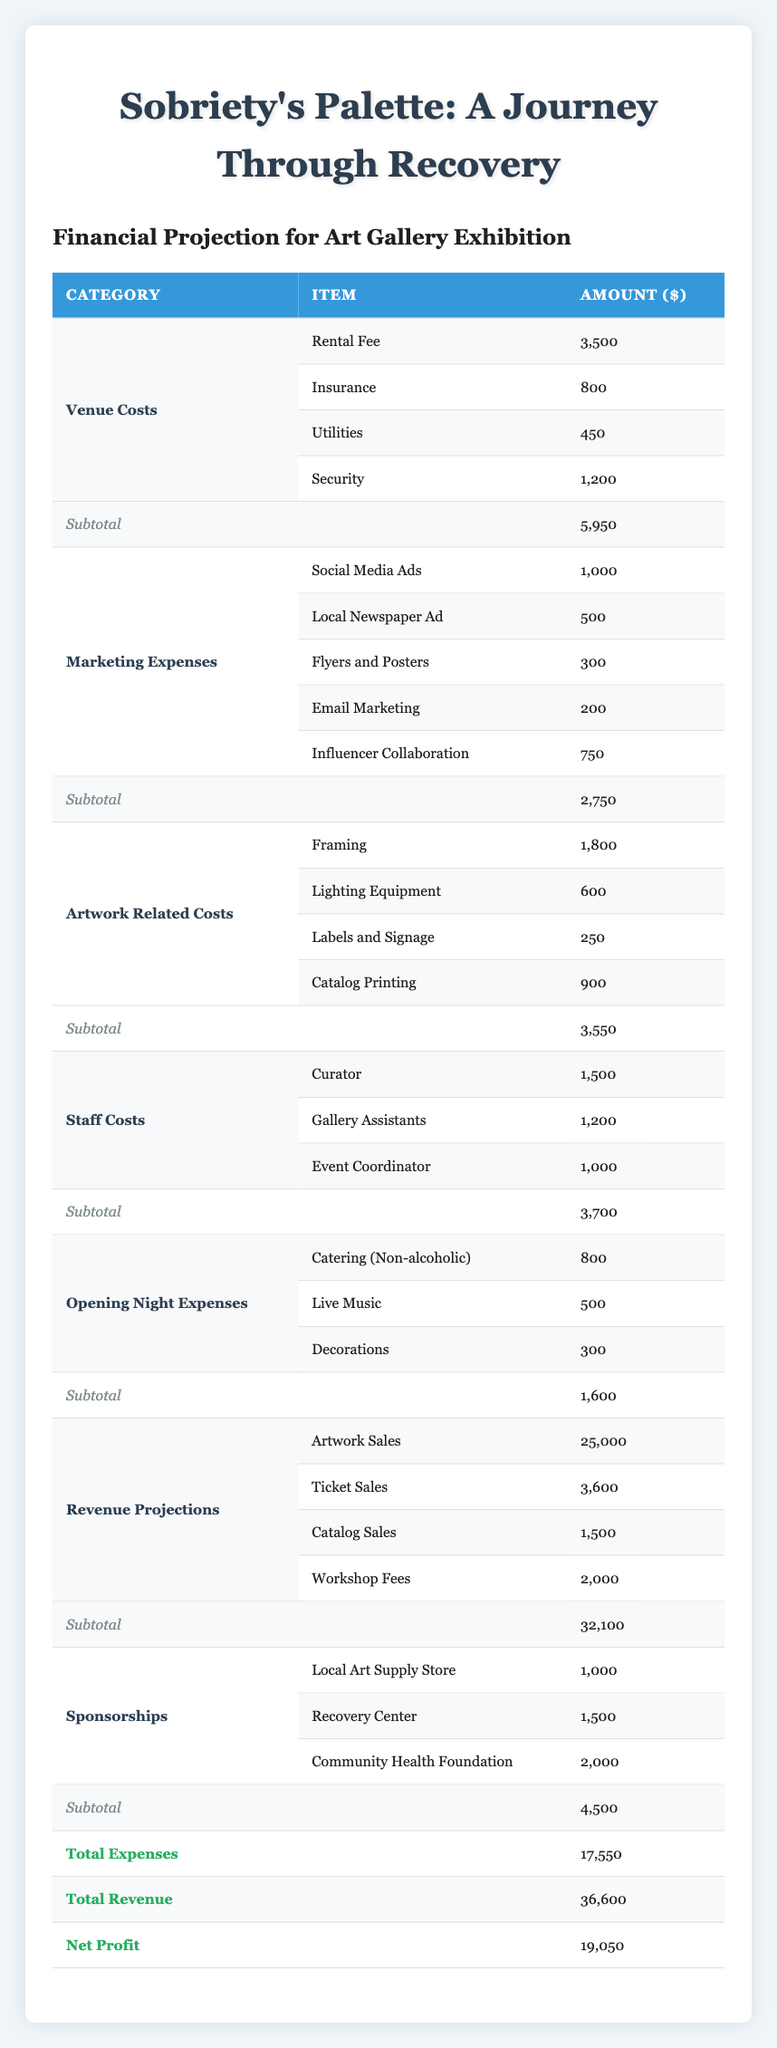What is the total cost for venue expenses? To find the total cost for venue expenses, we sum up the individual costs listed under the venue costs section: 3500 (Rental Fee) + 800 (Insurance) + 450 (Utilities) + 1200 (Security) = 5950.
Answer: 5950 What are the total marketing expenses? To calculate the total marketing expenses, we add up the amounts for social media ads, local newspaper ad, flyers and posters, email marketing, and influencer collaboration: 1000 + 500 + 300 + 200 + 750 = 2750.
Answer: 2750 Is the total revenue greater than the total expenses? We compare the total revenue (36600) to total expenses (17550). Since 36600 is greater than 17550, the statement is true.
Answer: Yes What is the net profit from the exhibition? The net profit can be determined by subtracting total expenses from total revenue: 36600 (Total Revenue) - 17550 (Total Expenses) = 19050.
Answer: 19050 If you were to halve the opening night expenses, what would the new total be? The current opening night expenses are 1600. Halving this gives us 1600 / 2 = 800. Adding this to the original total expenses of 17550 minus the original opening night expenses gives us: 17550 - 1600 + 800 = 17650.
Answer: 17650 What is the combined total of sponsorships? To find the combined total of sponsorships, we add the amounts for Local Art Supply Store (1000), Recovery Center (1500), and Community Health Foundation (2000): 1000 + 1500 + 2000 = 4500.
Answer: 4500 How much are the total artwork-related costs? We sum the costs listed under artwork-related costs: 1800 (Framing) + 600 (Lighting Equipment) + 250 (Labels and Signage) + 900 (Catalog Printing) = 3550.
Answer: 3550 What percentage of total revenue comes from artwork sales? To find the percentage of total revenue that comes from artwork sales: (25000 / 36600) * 100 = 68.3%.
Answer: 68.3% Are utilities more expensive than insurance? We compare the costs: Utilities are 450, and Insurance is 800. Since 450 is less than 800, the statement is false.
Answer: No 